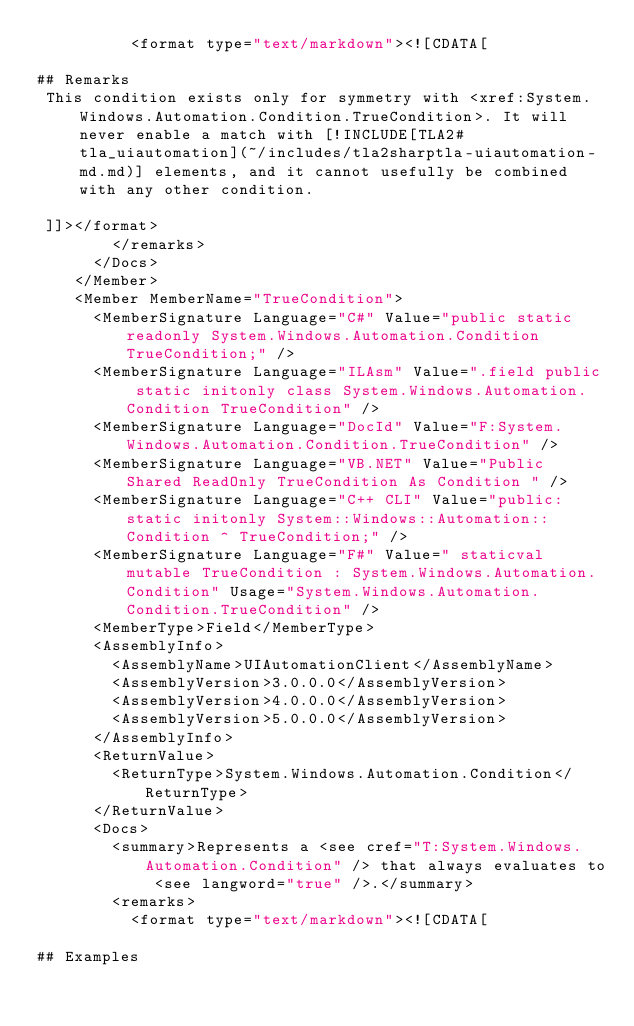<code> <loc_0><loc_0><loc_500><loc_500><_XML_>          <format type="text/markdown"><![CDATA[  
  
## Remarks  
 This condition exists only for symmetry with <xref:System.Windows.Automation.Condition.TrueCondition>. It will never enable a match with [!INCLUDE[TLA2#tla_uiautomation](~/includes/tla2sharptla-uiautomation-md.md)] elements, and it cannot usefully be combined with any other condition.  
  
 ]]></format>
        </remarks>
      </Docs>
    </Member>
    <Member MemberName="TrueCondition">
      <MemberSignature Language="C#" Value="public static readonly System.Windows.Automation.Condition TrueCondition;" />
      <MemberSignature Language="ILAsm" Value=".field public static initonly class System.Windows.Automation.Condition TrueCondition" />
      <MemberSignature Language="DocId" Value="F:System.Windows.Automation.Condition.TrueCondition" />
      <MemberSignature Language="VB.NET" Value="Public Shared ReadOnly TrueCondition As Condition " />
      <MemberSignature Language="C++ CLI" Value="public: static initonly System::Windows::Automation::Condition ^ TrueCondition;" />
      <MemberSignature Language="F#" Value=" staticval mutable TrueCondition : System.Windows.Automation.Condition" Usage="System.Windows.Automation.Condition.TrueCondition" />
      <MemberType>Field</MemberType>
      <AssemblyInfo>
        <AssemblyName>UIAutomationClient</AssemblyName>
        <AssemblyVersion>3.0.0.0</AssemblyVersion>
        <AssemblyVersion>4.0.0.0</AssemblyVersion>
        <AssemblyVersion>5.0.0.0</AssemblyVersion>
      </AssemblyInfo>
      <ReturnValue>
        <ReturnType>System.Windows.Automation.Condition</ReturnType>
      </ReturnValue>
      <Docs>
        <summary>Represents a <see cref="T:System.Windows.Automation.Condition" /> that always evaluates to <see langword="true" />.</summary>
        <remarks>
          <format type="text/markdown"><![CDATA[  
  
## Examples  </code> 